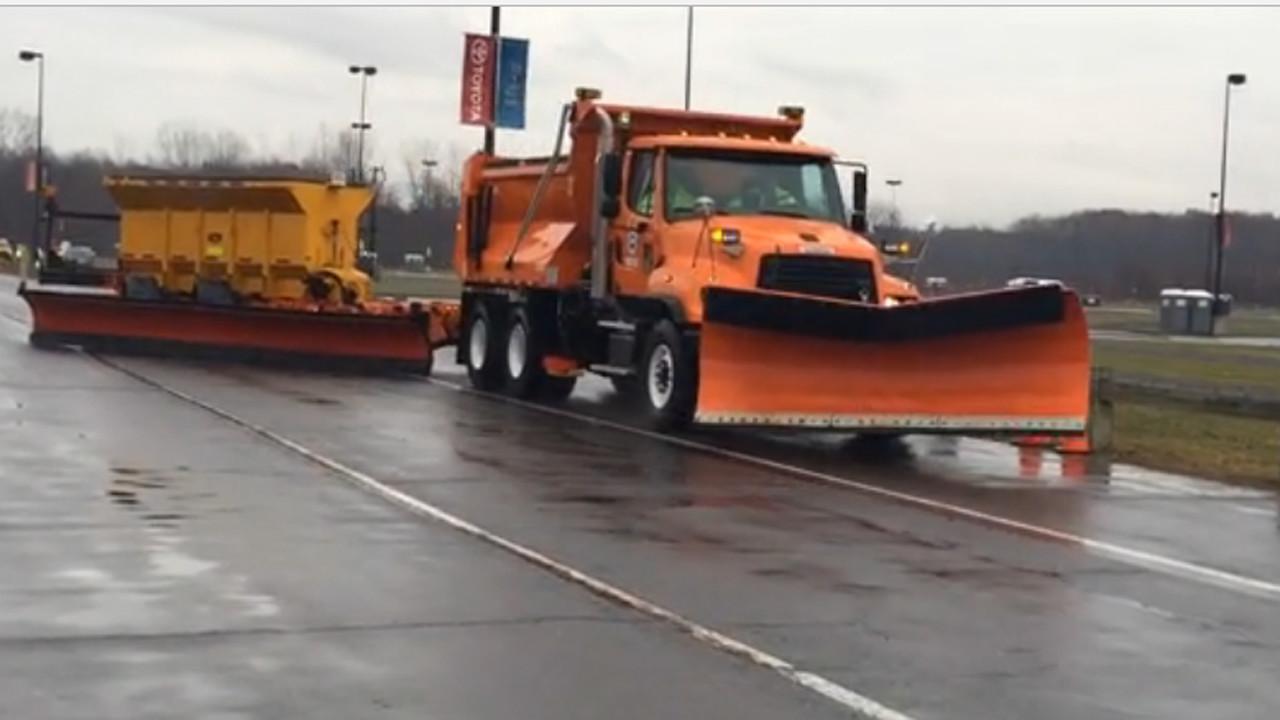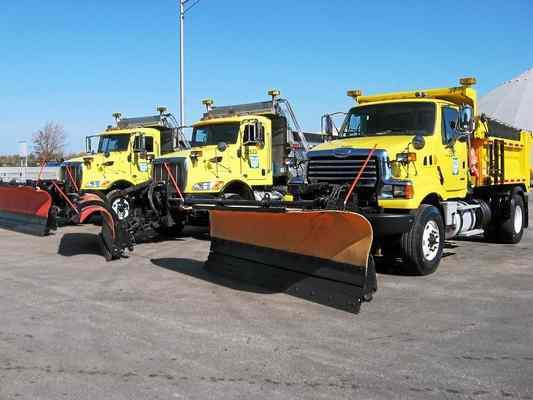The first image is the image on the left, the second image is the image on the right. Analyze the images presented: Is the assertion "An image includes a truck with an orange plow and a white cab." valid? Answer yes or no. No. The first image is the image on the left, the second image is the image on the right. For the images shown, is this caption "There is one snow plow in the image on the right." true? Answer yes or no. No. 